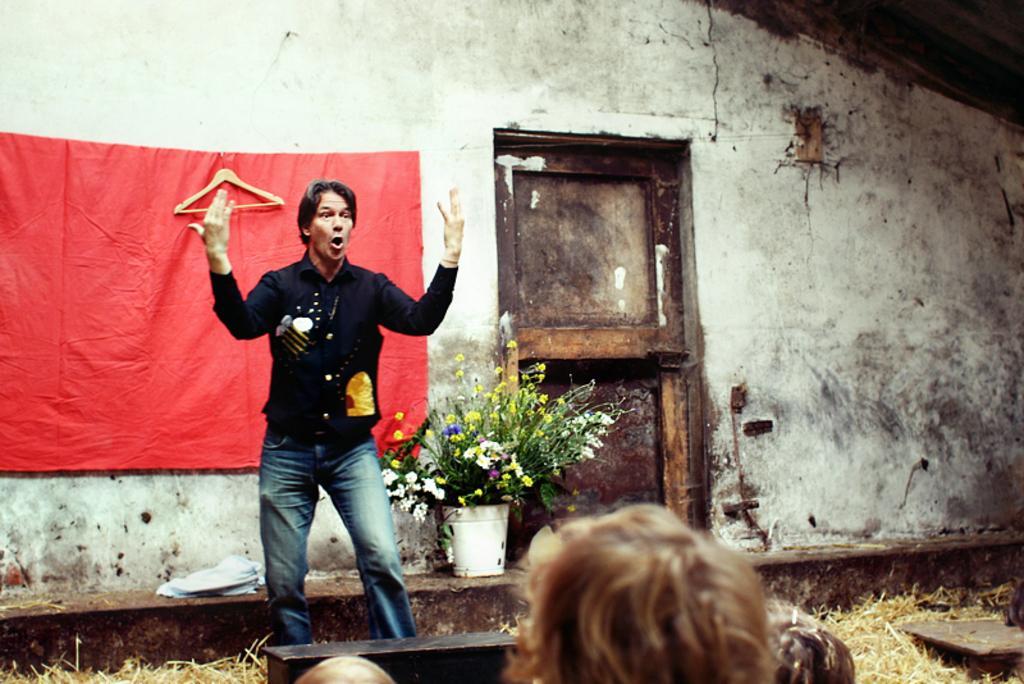Please provide a concise description of this image. In this image we can see a person talking. Behind the person we can see a wall, cloth, hanger, door and a houseplant. At the bottom we can see the persons and wooden objects. 